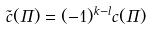<formula> <loc_0><loc_0><loc_500><loc_500>\tilde { c } ( \Pi ) = ( - 1 ) ^ { k - l } c ( \Pi )</formula> 